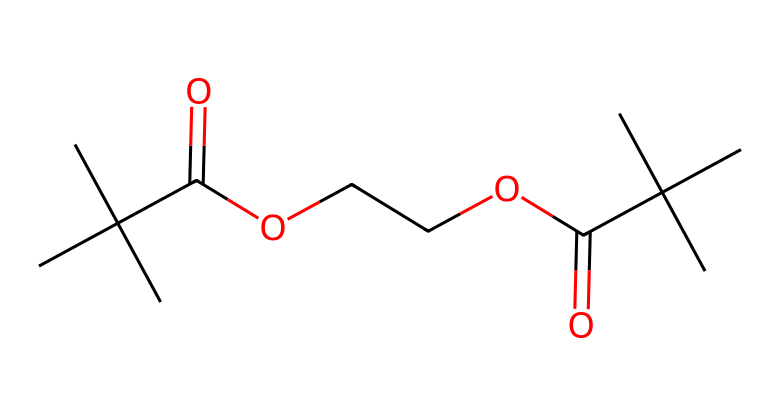What is the total number of carbon atoms in this molecule? By analyzing the SMILES representation, we can count the number of carbon atoms present. The 'C' indicates a carbon atom, and by examining the structure, there are 12 carbon atoms total.
Answer: 12 How many oxygen atoms are present in the compound? In the provided SMILES, we can identify the 'O' symbols indicating oxygen atoms. Counting each 'O' reveals there are 4 oxygen atoms in total.
Answer: 4 What type of functional groups can be identified in this molecule? By inspecting the structure, we see the presence of ester groups (denoted by the -O- that connects two carbon-based groups and a carbonyl (C=O)). These characteristics signify that the molecule contains both ester and carboxylic acid functional groups.
Answer: ester and carboxylic acid What is the molecular formula for the chemical represented by the given SMILES? To determine the molecular formula, we must count the number of carbon, hydrogen, and oxygen atoms: C12, H22, O4 gives us the molecular formula C12H22O4 for the chemical.
Answer: C12H22O4 Is this compound likely to be soluble in organic solvents? Considering the presence of polar functional groups (like carbonyl and hydroxyl), this structure implies a degree of polarity, suggesting that the compound may exhibit some polar characteristics; however, its mostly carbon-based nature indicates it is more likely to be soluble in non-polar organic solvents rather than in water.
Answer: yes What type of polymer might this structure represent in photoresists? This structure can represent a light-sensitive polymer used in photoresists. The presence of ester linkages alongside functional groups associated with light sensitivity indicates its potential application in film formation and lithographic processes.
Answer: light-sensitive polymer 